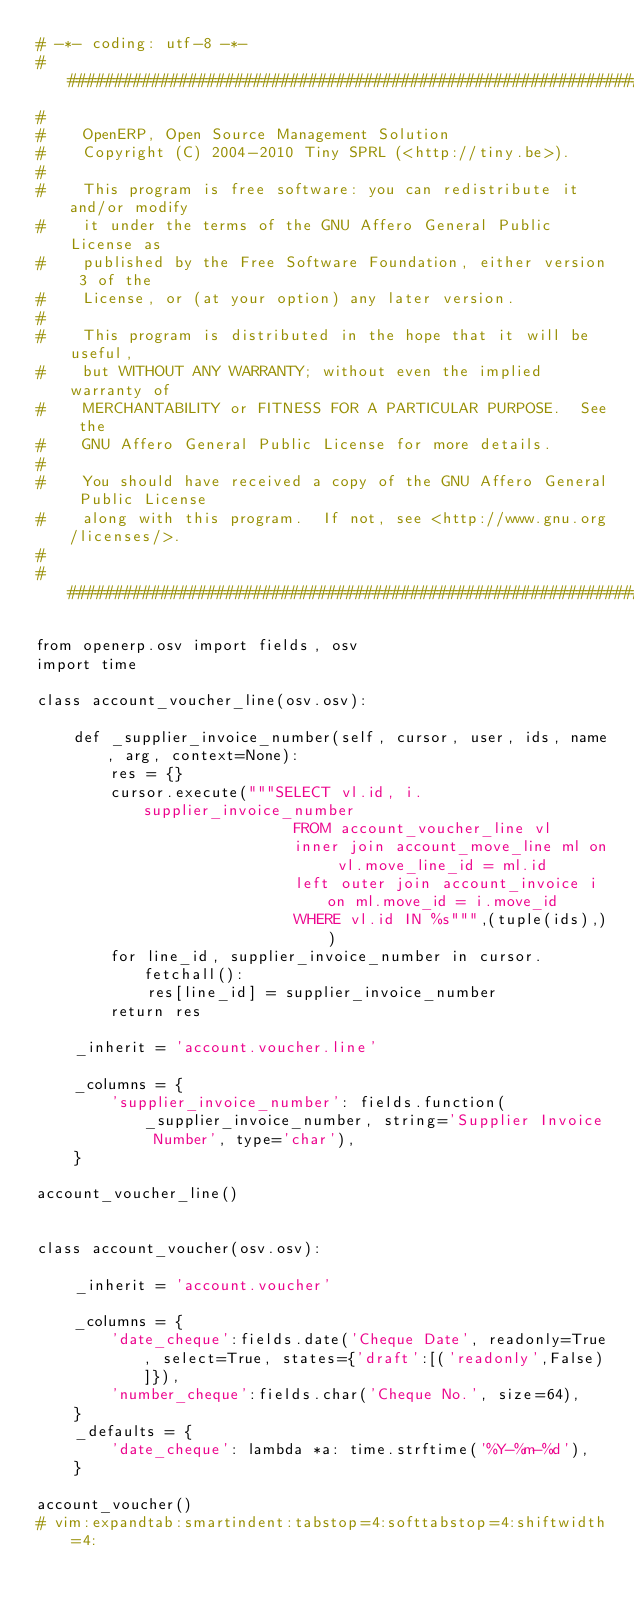Convert code to text. <code><loc_0><loc_0><loc_500><loc_500><_Python_># -*- coding: utf-8 -*-
##############################################################################
#
#    OpenERP, Open Source Management Solution
#    Copyright (C) 2004-2010 Tiny SPRL (<http://tiny.be>).
#
#    This program is free software: you can redistribute it and/or modify
#    it under the terms of the GNU Affero General Public License as
#    published by the Free Software Foundation, either version 3 of the
#    License, or (at your option) any later version.
#
#    This program is distributed in the hope that it will be useful,
#    but WITHOUT ANY WARRANTY; without even the implied warranty of
#    MERCHANTABILITY or FITNESS FOR A PARTICULAR PURPOSE.  See the
#    GNU Affero General Public License for more details.
#
#    You should have received a copy of the GNU Affero General Public License
#    along with this program.  If not, see <http://www.gnu.org/licenses/>.
#
##############################################################################

from openerp.osv import fields, osv
import time

class account_voucher_line(osv.osv):
    
    def _supplier_invoice_number(self, cursor, user, ids, name, arg, context=None):
        res = {}
        cursor.execute("""SELECT vl.id, i.supplier_invoice_number
                            FROM account_voucher_line vl
                            inner join account_move_line ml on vl.move_line_id = ml.id
                            left outer join account_invoice i on ml.move_id = i.move_id
                            WHERE vl.id IN %s""",(tuple(ids),))
        for line_id, supplier_invoice_number in cursor.fetchall():
            res[line_id] = supplier_invoice_number
        return res
    
    _inherit = 'account.voucher.line'
    
    _columns = {
        'supplier_invoice_number': fields.function(_supplier_invoice_number, string='Supplier Invoice Number', type='char'),
    }

account_voucher_line()


class account_voucher(osv.osv):
    
    _inherit = 'account.voucher'
    
    _columns = {
        'date_cheque':fields.date('Cheque Date', readonly=True, select=True, states={'draft':[('readonly',False)]}),
        'number_cheque':fields.char('Cheque No.', size=64),
    }
    _defaults = {
        'date_cheque': lambda *a: time.strftime('%Y-%m-%d'),
    }

account_voucher()
# vim:expandtab:smartindent:tabstop=4:softtabstop=4:shiftwidth=4:
</code> 